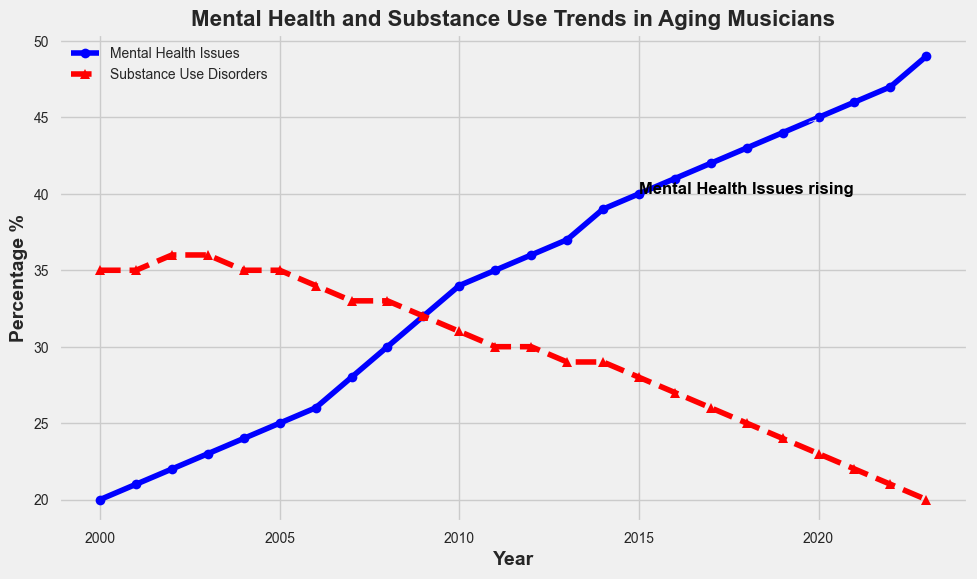What's the highest percentage of Mental Health Issues over the years 2000 to 2023? Looking at the line for Mental Health Issues, the highest point is in 2023 where it reaches approximately 49%.
Answer: 49% What is the difference in the percentage of Substance Use Disorders between 2000 and 2023? In 2000, Substance Use Disorders are at 35%. By 2023, they drop to 20%. The difference is 35% - 20% = 15%.
Answer: 15% How does the trend of Mental Health Issues compare to that of Substance Use Disorders from 2000 to 2023? The blue line representing Mental Health Issues shows a consistent upward trend, while the red dashed line for Substance Use Disorders shows a consistent downward trend.
Answer: Mental Health Issues are increasing, Substance Use Disorders are decreasing Are there any years where the percentage of Mental Health Issues and Substance Use Disorders are equal? By examining the two lines, we see that the lines never intersect. This means there are no years where the percentages are equal.
Answer: No What is the percentage change in Mental Health Issues from 2000 to 2023? The percentage increases from 20% in 2000 to 49% in 2023. The change is 49% - 20% = 29%.
Answer: 29% Which year marks the annotated text "Mental Health Issues rising"? The annotation points to the year 2020 with an arrow starting around 2015.
Answer: 2020 During which five-year period did Mental Health Issues increase the most rapidly? Observing the blue line, the steepest incline appears between 2015 and 2020.
Answer: 2015-2020 What happens to the percentage of Substance Use Disorders from 2010 to 2015? The red dashed line shows a downward trend from 31% in 2010 to 28% in 2015.
Answer: Decreases from 31% to 28% In which year did the percentage of Substance Use Disorders fall below the percentage of Mental Health Issues? Around 2007, Mental Health Issues began surpassing Substance Use Disorders.
Answer: 2007 Examine the trend in Mental Health Issues from 2008 to 2011. What can you conclude about its progression? The graph shows a continuous rise in Mental Health Issues from 2008 (30%) to 2011 (35%). This indicates a consistent upward progression over these years.
Answer: Consistent upward progression 